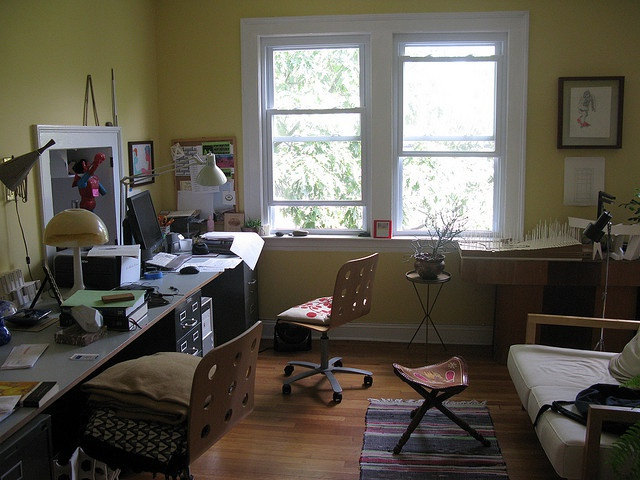Describe the objects in this image and their specific colors. I can see chair in darkgreen, black, gray, and maroon tones, couch in darkgreen, black, and gray tones, chair in darkgreen, black, gray, and maroon tones, potted plant in darkgreen, white, gray, black, and darkgray tones, and chair in darkgreen, black, gray, and maroon tones in this image. 